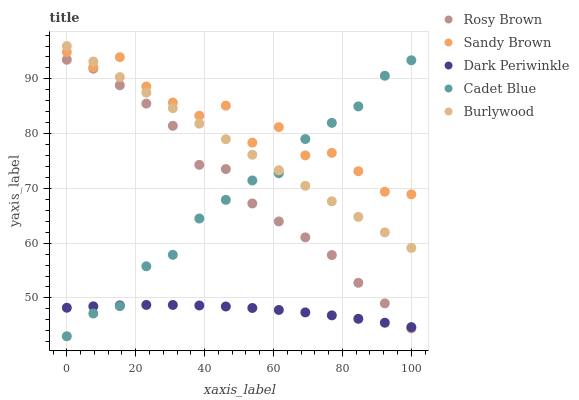Does Dark Periwinkle have the minimum area under the curve?
Answer yes or no. Yes. Does Sandy Brown have the maximum area under the curve?
Answer yes or no. Yes. Does Burlywood have the minimum area under the curve?
Answer yes or no. No. Does Burlywood have the maximum area under the curve?
Answer yes or no. No. Is Burlywood the smoothest?
Answer yes or no. Yes. Is Sandy Brown the roughest?
Answer yes or no. Yes. Is Rosy Brown the smoothest?
Answer yes or no. No. Is Rosy Brown the roughest?
Answer yes or no. No. Does Cadet Blue have the lowest value?
Answer yes or no. Yes. Does Burlywood have the lowest value?
Answer yes or no. No. Does Burlywood have the highest value?
Answer yes or no. Yes. Does Rosy Brown have the highest value?
Answer yes or no. No. Is Rosy Brown less than Burlywood?
Answer yes or no. Yes. Is Burlywood greater than Dark Periwinkle?
Answer yes or no. Yes. Does Cadet Blue intersect Sandy Brown?
Answer yes or no. Yes. Is Cadet Blue less than Sandy Brown?
Answer yes or no. No. Is Cadet Blue greater than Sandy Brown?
Answer yes or no. No. Does Rosy Brown intersect Burlywood?
Answer yes or no. No. 